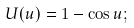<formula> <loc_0><loc_0><loc_500><loc_500>U ( u ) = 1 - \cos u ;</formula> 